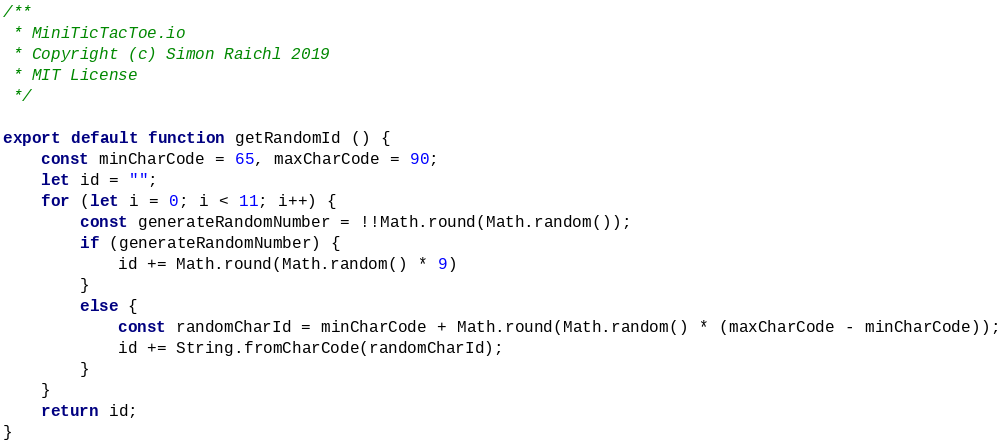<code> <loc_0><loc_0><loc_500><loc_500><_JavaScript_>/**
 * MiniTicTacToe.io
 * Copyright (c) Simon Raichl 2019
 * MIT License
 */

export default function getRandomId () {
    const minCharCode = 65, maxCharCode = 90;
    let id = "";
    for (let i = 0; i < 11; i++) {
        const generateRandomNumber = !!Math.round(Math.random());
        if (generateRandomNumber) {
            id += Math.round(Math.random() * 9)
        }
        else {
            const randomCharId = minCharCode + Math.round(Math.random() * (maxCharCode - minCharCode));
            id += String.fromCharCode(randomCharId);
        }
    }
    return id;
}</code> 